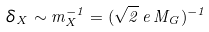<formula> <loc_0><loc_0><loc_500><loc_500>\delta _ { X } \sim m _ { X } ^ { - 1 } = ( \sqrt { 2 } \, e \, M _ { G } ) ^ { - 1 }</formula> 